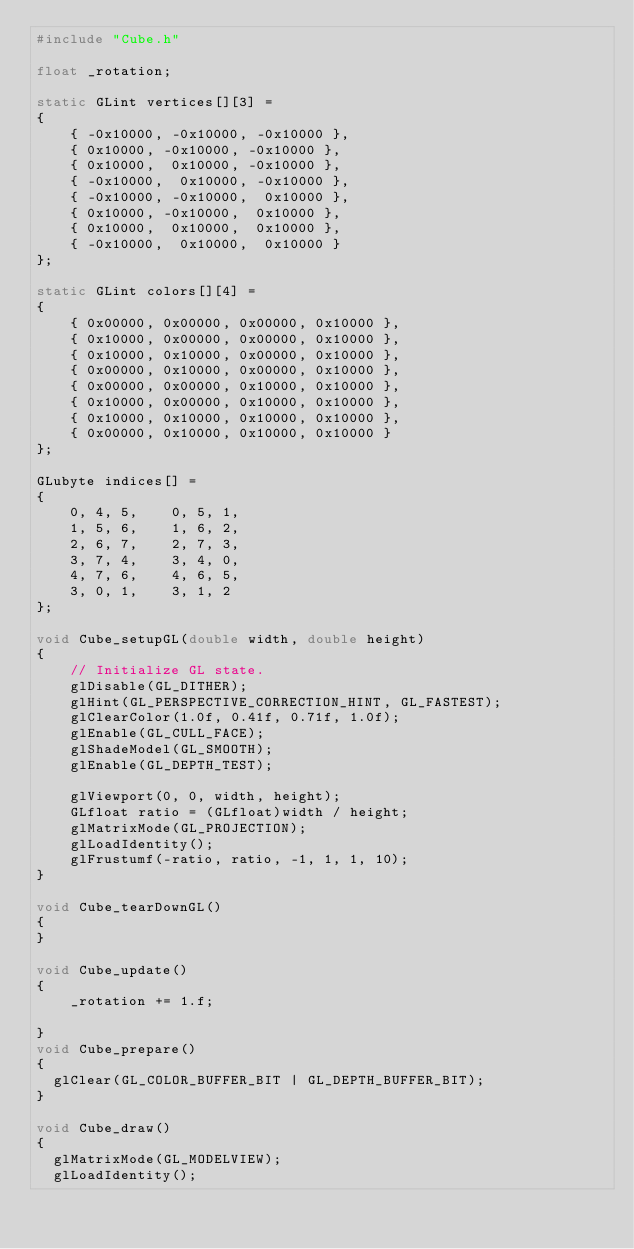<code> <loc_0><loc_0><loc_500><loc_500><_C++_>#include "Cube.h"

float _rotation;

static GLint vertices[][3] =
{
    { -0x10000, -0x10000, -0x10000 },
    { 0x10000, -0x10000, -0x10000 },
    { 0x10000,  0x10000, -0x10000 },
    { -0x10000,  0x10000, -0x10000 },
    { -0x10000, -0x10000,  0x10000 },
    { 0x10000, -0x10000,  0x10000 },
    { 0x10000,  0x10000,  0x10000 },
    { -0x10000,  0x10000,  0x10000 }
};

static GLint colors[][4] =
{
    { 0x00000, 0x00000, 0x00000, 0x10000 },
    { 0x10000, 0x00000, 0x00000, 0x10000 },
    { 0x10000, 0x10000, 0x00000, 0x10000 },
    { 0x00000, 0x10000, 0x00000, 0x10000 },
    { 0x00000, 0x00000, 0x10000, 0x10000 },
    { 0x10000, 0x00000, 0x10000, 0x10000 },
    { 0x10000, 0x10000, 0x10000, 0x10000 },
    { 0x00000, 0x10000, 0x10000, 0x10000 }
};

GLubyte indices[] =
{
    0, 4, 5,    0, 5, 1,
    1, 5, 6,    1, 6, 2,
    2, 6, 7,    2, 7, 3,
    3, 7, 4,    3, 4, 0,
    4, 7, 6,    4, 6, 5,
    3, 0, 1,    3, 1, 2
};

void Cube_setupGL(double width, double height)
{
    // Initialize GL state.
    glDisable(GL_DITHER);
    glHint(GL_PERSPECTIVE_CORRECTION_HINT, GL_FASTEST);
    glClearColor(1.0f, 0.41f, 0.71f, 1.0f);
    glEnable(GL_CULL_FACE);
    glShadeModel(GL_SMOOTH);
    glEnable(GL_DEPTH_TEST);

    glViewport(0, 0, width, height);
    GLfloat ratio = (GLfloat)width / height;
    glMatrixMode(GL_PROJECTION);
    glLoadIdentity();
    glFrustumf(-ratio, ratio, -1, 1, 1, 10);
}

void Cube_tearDownGL()
{
}

void Cube_update()
{
    _rotation += 1.f;

}
void Cube_prepare()
{
	glClear(GL_COLOR_BUFFER_BIT | GL_DEPTH_BUFFER_BIT);
}

void Cube_draw()
{
	glMatrixMode(GL_MODELVIEW);
	glLoadIdentity();</code> 